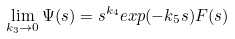<formula> <loc_0><loc_0><loc_500><loc_500>\lim _ { k _ { 3 } \rightarrow 0 } \Psi ( s ) = s ^ { k _ { 4 } } e x p ( - k _ { 5 } s ) F ( s )</formula> 